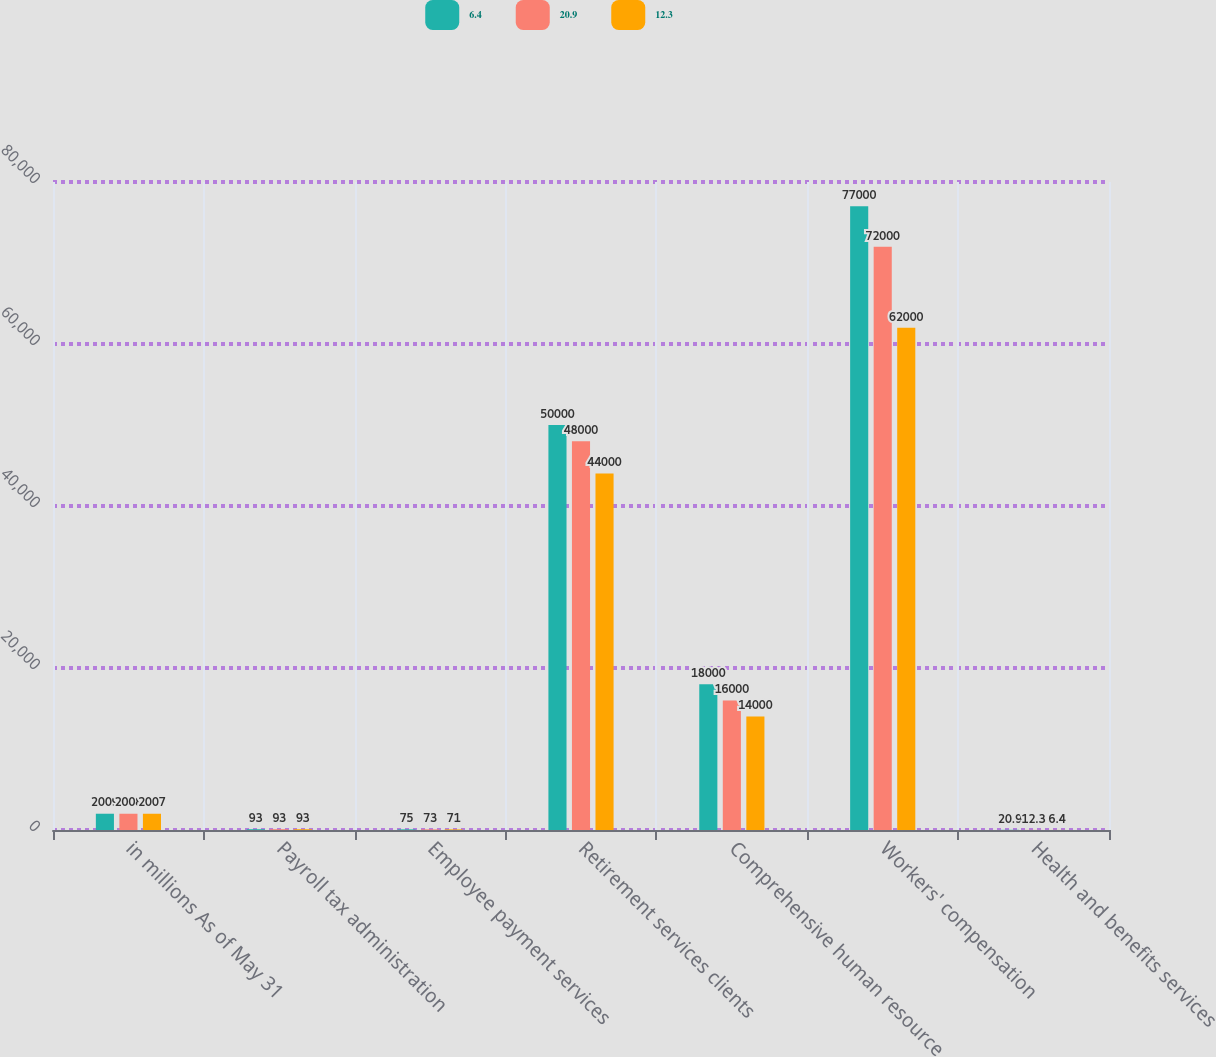Convert chart to OTSL. <chart><loc_0><loc_0><loc_500><loc_500><stacked_bar_chart><ecel><fcel>in millions As of May 31<fcel>Payroll tax administration<fcel>Employee payment services<fcel>Retirement services clients<fcel>Comprehensive human resource<fcel>Workers' compensation<fcel>Health and benefits services<nl><fcel>6.4<fcel>2009<fcel>93<fcel>75<fcel>50000<fcel>18000<fcel>77000<fcel>20.9<nl><fcel>20.9<fcel>2008<fcel>93<fcel>73<fcel>48000<fcel>16000<fcel>72000<fcel>12.3<nl><fcel>12.3<fcel>2007<fcel>93<fcel>71<fcel>44000<fcel>14000<fcel>62000<fcel>6.4<nl></chart> 